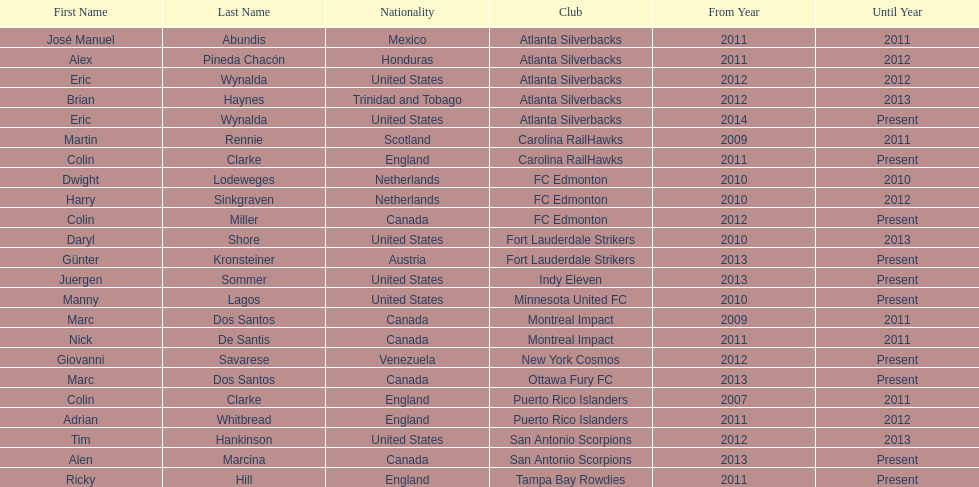How long did colin clarke coach the puerto rico islanders? 4 years. 